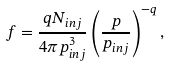<formula> <loc_0><loc_0><loc_500><loc_500>f = \frac { q N _ { i n j } } { 4 \pi p _ { i n j } ^ { 3 } } \left ( \frac { p } { p _ { i n j } } \right ) ^ { - q } ,</formula> 